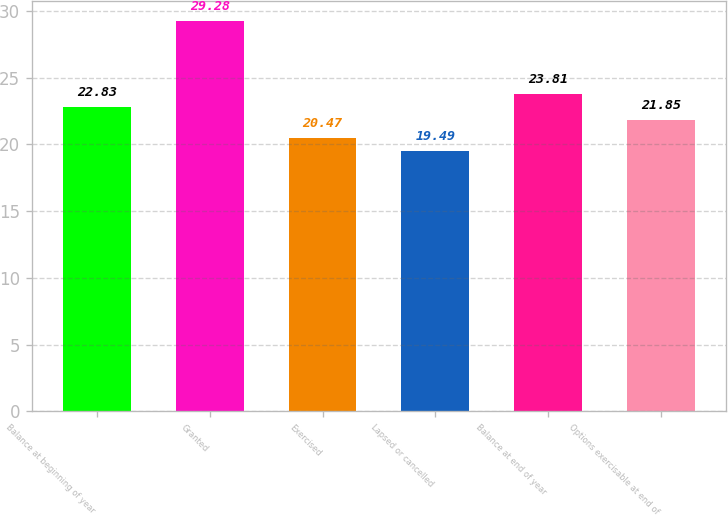<chart> <loc_0><loc_0><loc_500><loc_500><bar_chart><fcel>Balance at beginning of year<fcel>Granted<fcel>Exercised<fcel>Lapsed or cancelled<fcel>Balance at end of year<fcel>Options exercisable at end of<nl><fcel>22.83<fcel>29.28<fcel>20.47<fcel>19.49<fcel>23.81<fcel>21.85<nl></chart> 